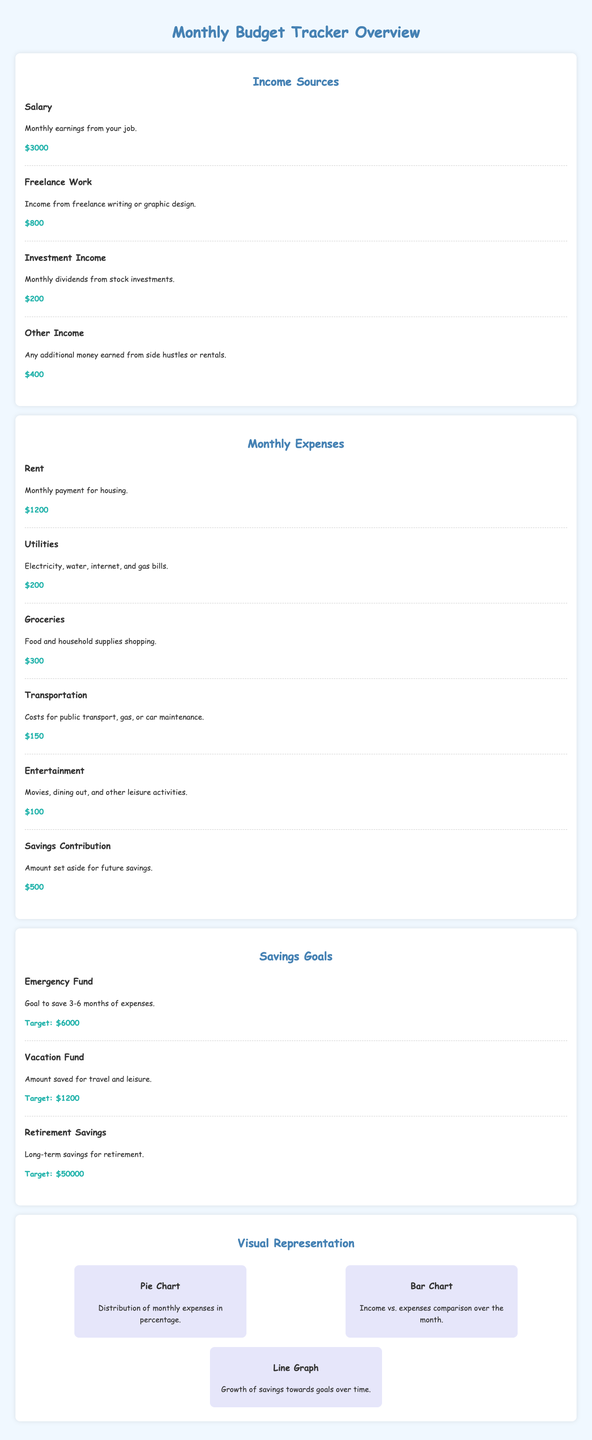What is the total income? The total income is the sum of all income sources: $3000 + $800 + $200 + $400 = $4400.
Answer: $4400 What is the monthly rent? The monthly rent payment listed in the document is specified in the expenses section.
Answer: $1200 What is the target for the emergency fund? The target for the emergency fund can be found in the savings goals section.
Answer: $6000 How much is contributed to savings each month? The amount set aside for savings in monthly expenses is provided in the document.
Answer: $500 What is the income from freelance work? The specific income from freelance work is mentioned in the income sources section.
Answer: $800 Which chart compares income vs. expenses? The document specifies which chart serves this purpose under the visual representation section.
Answer: Bar Chart What type of graph is used to show the growth of savings? The type of graph that illustrates savings growth over time can be identified in the visual representation section.
Answer: Line Graph How much is spent on groceries monthly? The document states the amount allocated to groceries in the monthly expenses section.
Answer: $300 What is the target for the vacation fund? The target amount for the vacation fund is detailed in the savings goals section.
Answer: $1200 